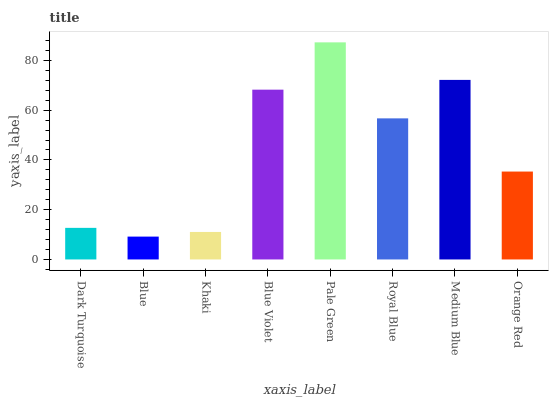Is Blue the minimum?
Answer yes or no. Yes. Is Pale Green the maximum?
Answer yes or no. Yes. Is Khaki the minimum?
Answer yes or no. No. Is Khaki the maximum?
Answer yes or no. No. Is Khaki greater than Blue?
Answer yes or no. Yes. Is Blue less than Khaki?
Answer yes or no. Yes. Is Blue greater than Khaki?
Answer yes or no. No. Is Khaki less than Blue?
Answer yes or no. No. Is Royal Blue the high median?
Answer yes or no. Yes. Is Orange Red the low median?
Answer yes or no. Yes. Is Khaki the high median?
Answer yes or no. No. Is Blue Violet the low median?
Answer yes or no. No. 